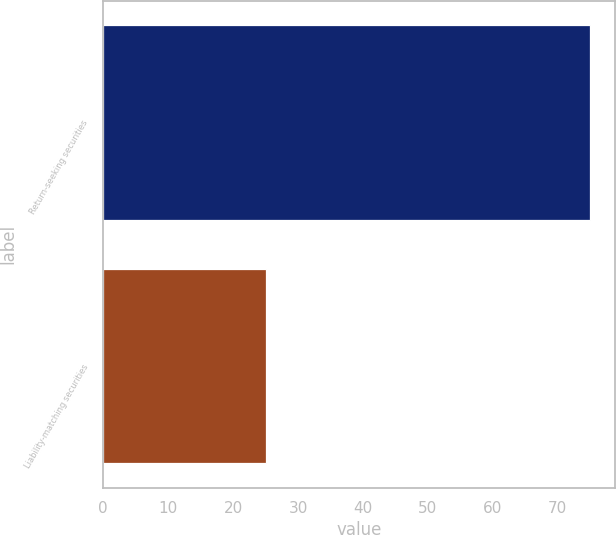Convert chart. <chart><loc_0><loc_0><loc_500><loc_500><bar_chart><fcel>Return-seeking securities<fcel>Liability-matching securities<nl><fcel>75<fcel>25<nl></chart> 